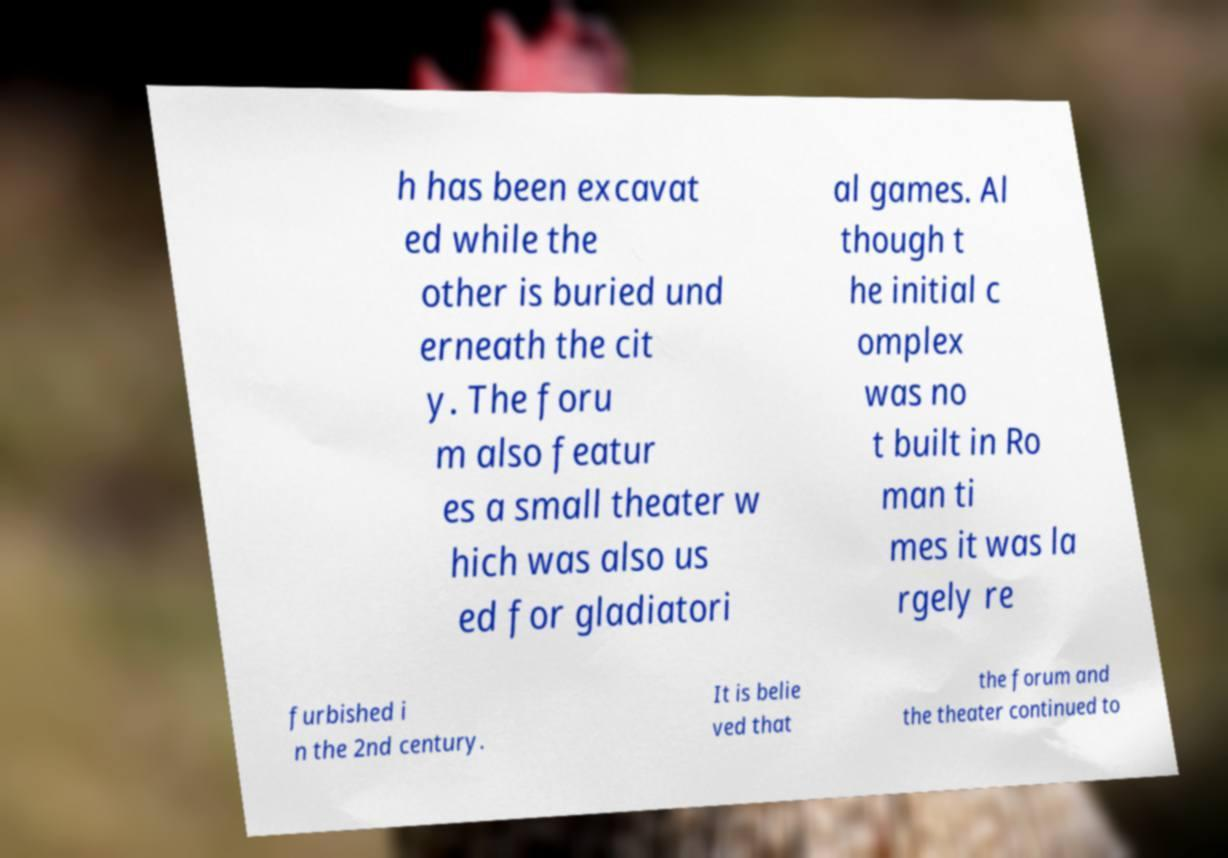What messages or text are displayed in this image? I need them in a readable, typed format. h has been excavat ed while the other is buried und erneath the cit y. The foru m also featur es a small theater w hich was also us ed for gladiatori al games. Al though t he initial c omplex was no t built in Ro man ti mes it was la rgely re furbished i n the 2nd century. It is belie ved that the forum and the theater continued to 